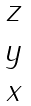<formula> <loc_0><loc_0><loc_500><loc_500>\begin{matrix} z \\ y \\ x \end{matrix}</formula> 